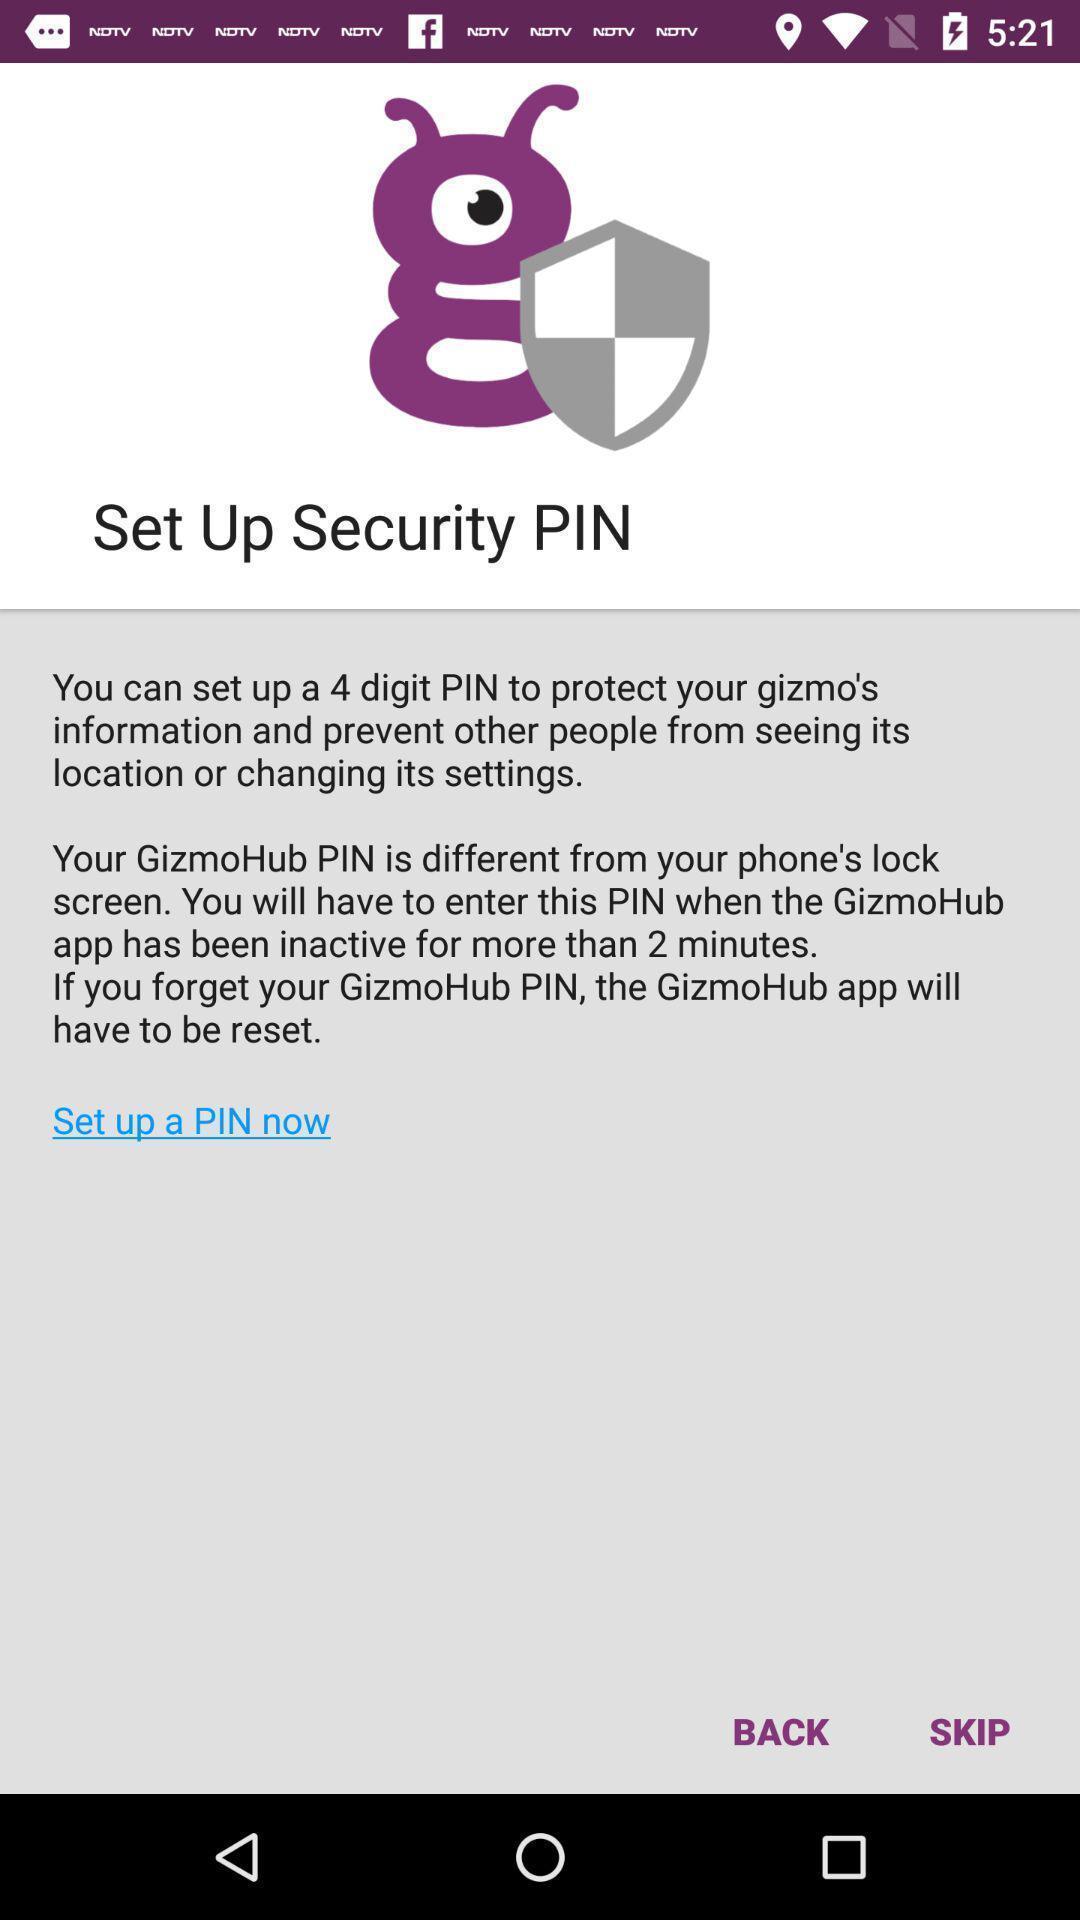Describe this image in words. Page for setting security pin for an app. 